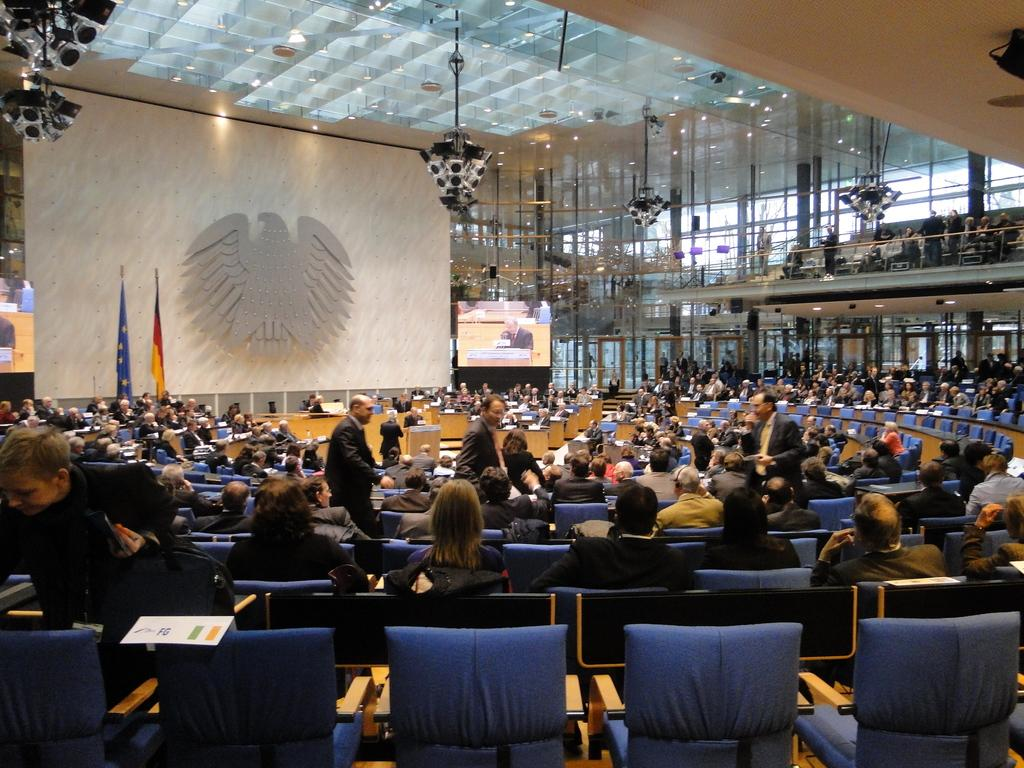How many people are in the image? There is a group of people in the image, but the exact number cannot be determined from the provided facts. What are some people doing in the image? Some people are sitting on chairs, while others are standing. What can be seen on the screens in the image? The provided facts do not specify what is displayed on the screens. What type of lighting is present in the image? There are lights in the image, but their specific type or intensity is not mentioned. What do the flags in the image represent? The provided facts do not specify what the flags represent or their significance. What other objects are present in the image? There are other objects present in the image, but their specific nature is not mentioned. What type of book is being read by the person in the image? There is no person reading a book in the image, nor is there any mention of a book in the provided facts. 